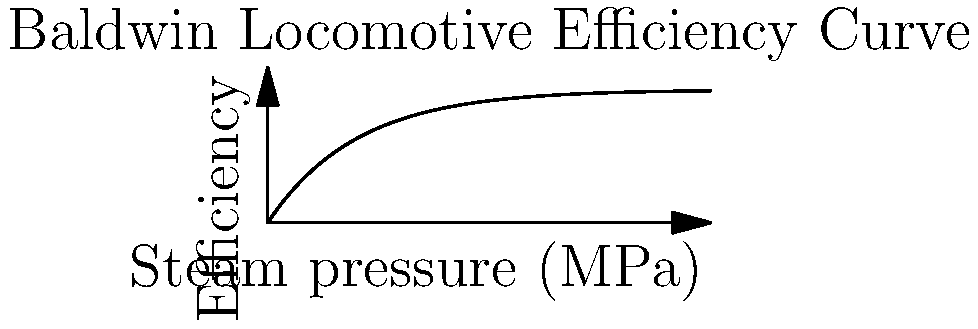The historic Baldwin Locomotive Works, founded in Philadelphia, was known for its steam engines. Consider a Baldwin steam engine with an efficiency curve described by the equation $\eta = 0.6(1-e^{-P/0.4})$, where $\eta$ is the efficiency and $P$ is the steam pressure in MPa. At what steam pressure does the engine achieve 90% of its maximum theoretical efficiency? To solve this problem, let's follow these steps:

1) First, we need to determine the maximum theoretical efficiency. As $P$ approaches infinity, $e^{-P/0.4}$ approaches 0, so:

   $\eta_{max} = 0.6(1-0) = 0.6$ or 60%

2) We're looking for 90% of this maximum, which is:

   $0.9 \times 0.6 = 0.54$ or 54%

3) Now, we can set up our equation:

   $0.54 = 0.6(1-e^{-P/0.4})$

4) Solve for $P$:
   
   $0.9 = 1-e^{-P/0.4}$
   $0.1 = e^{-P/0.4}$
   $\ln(0.1) = -P/0.4$
   $-2.3026 = -P/0.4$
   $P = 0.4 \times 2.3026 = 0.9210$ MPa

5) Rounding to two decimal places:

   $P = 0.92$ MPa

This pressure achieves 90% of the maximum theoretical efficiency.
Answer: 0.92 MPa 